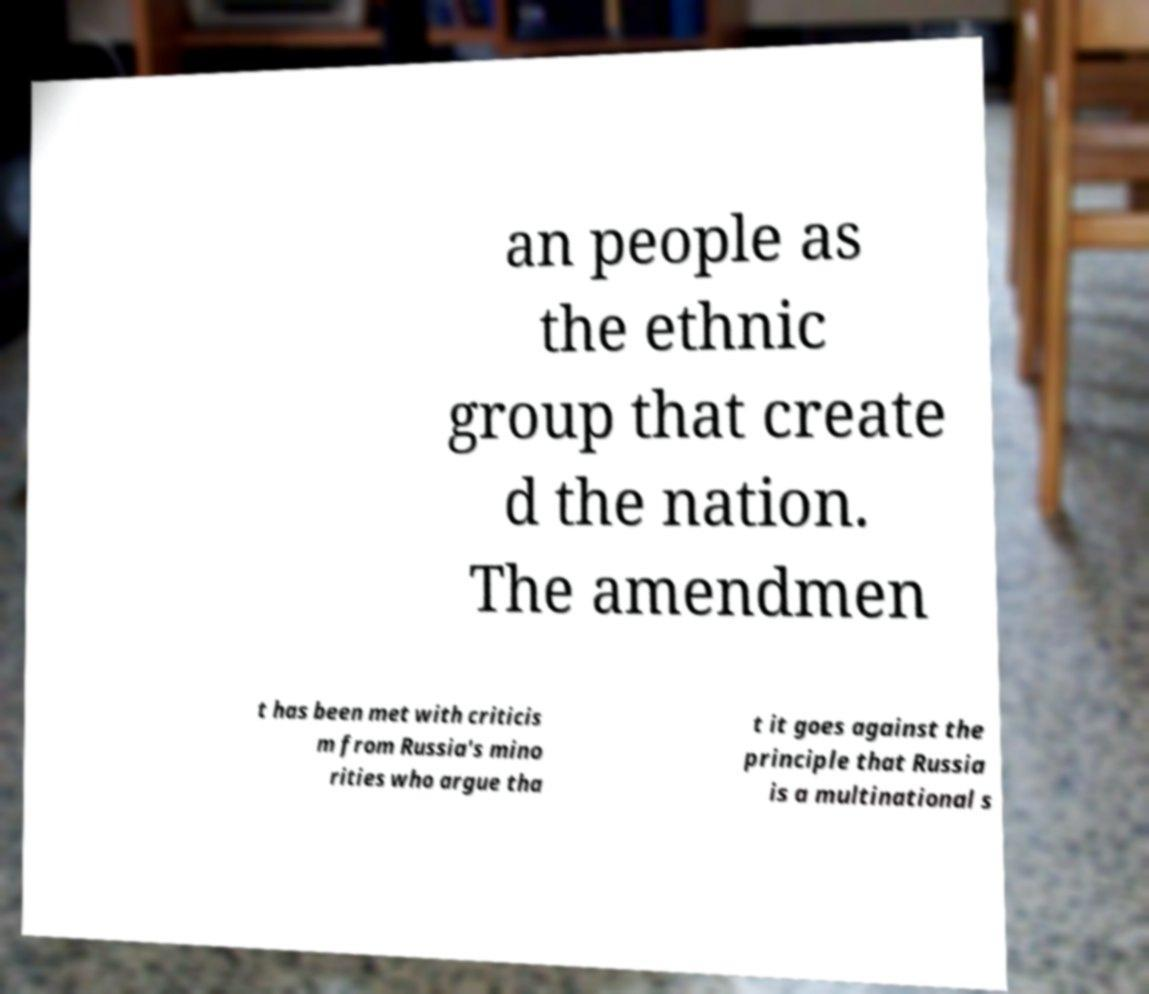Could you extract and type out the text from this image? an people as the ethnic group that create d the nation. The amendmen t has been met with criticis m from Russia's mino rities who argue tha t it goes against the principle that Russia is a multinational s 